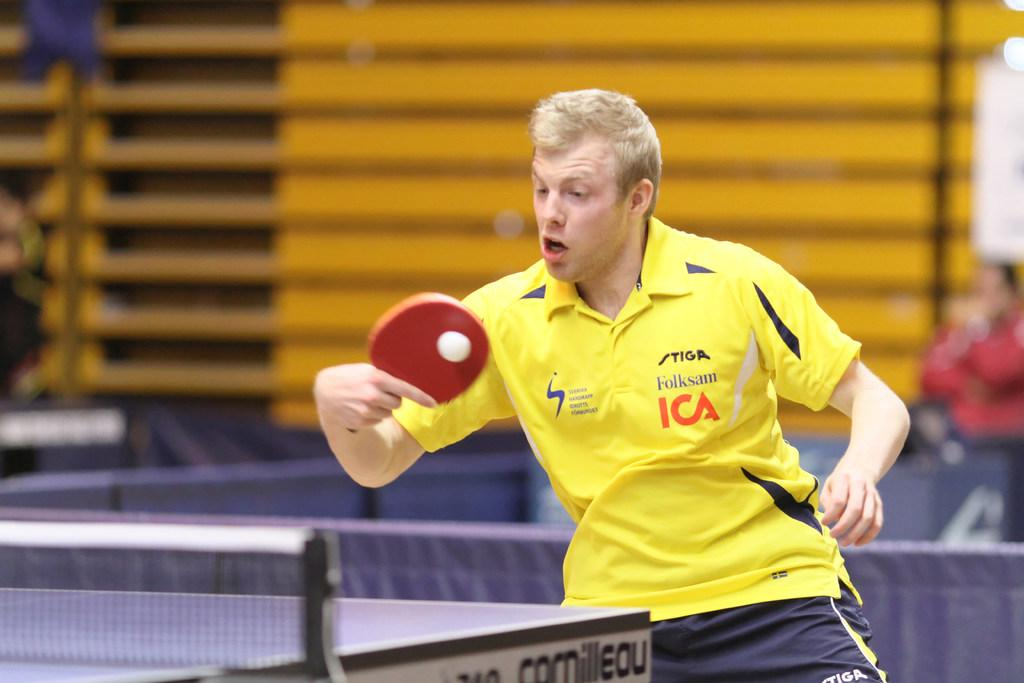<image>
Share a concise interpretation of the image provided. A male playing pingpong in a yellow Folksam ICA polo shirt. 